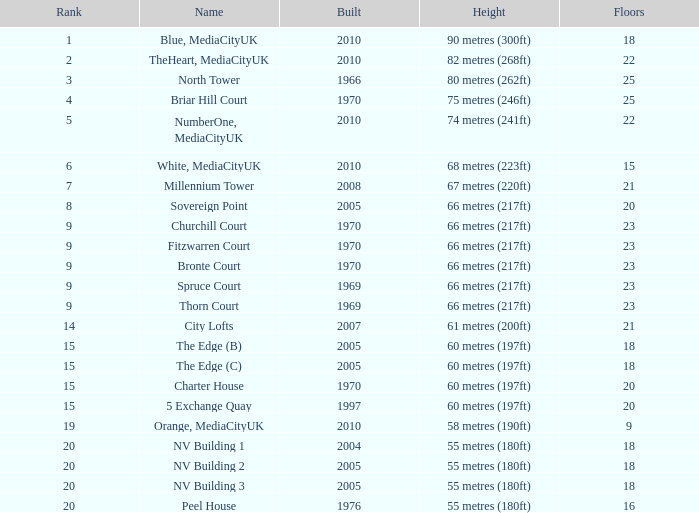What is the lowest Built, when Floors is greater than 23, and when Rank is 3? 1966.0. 